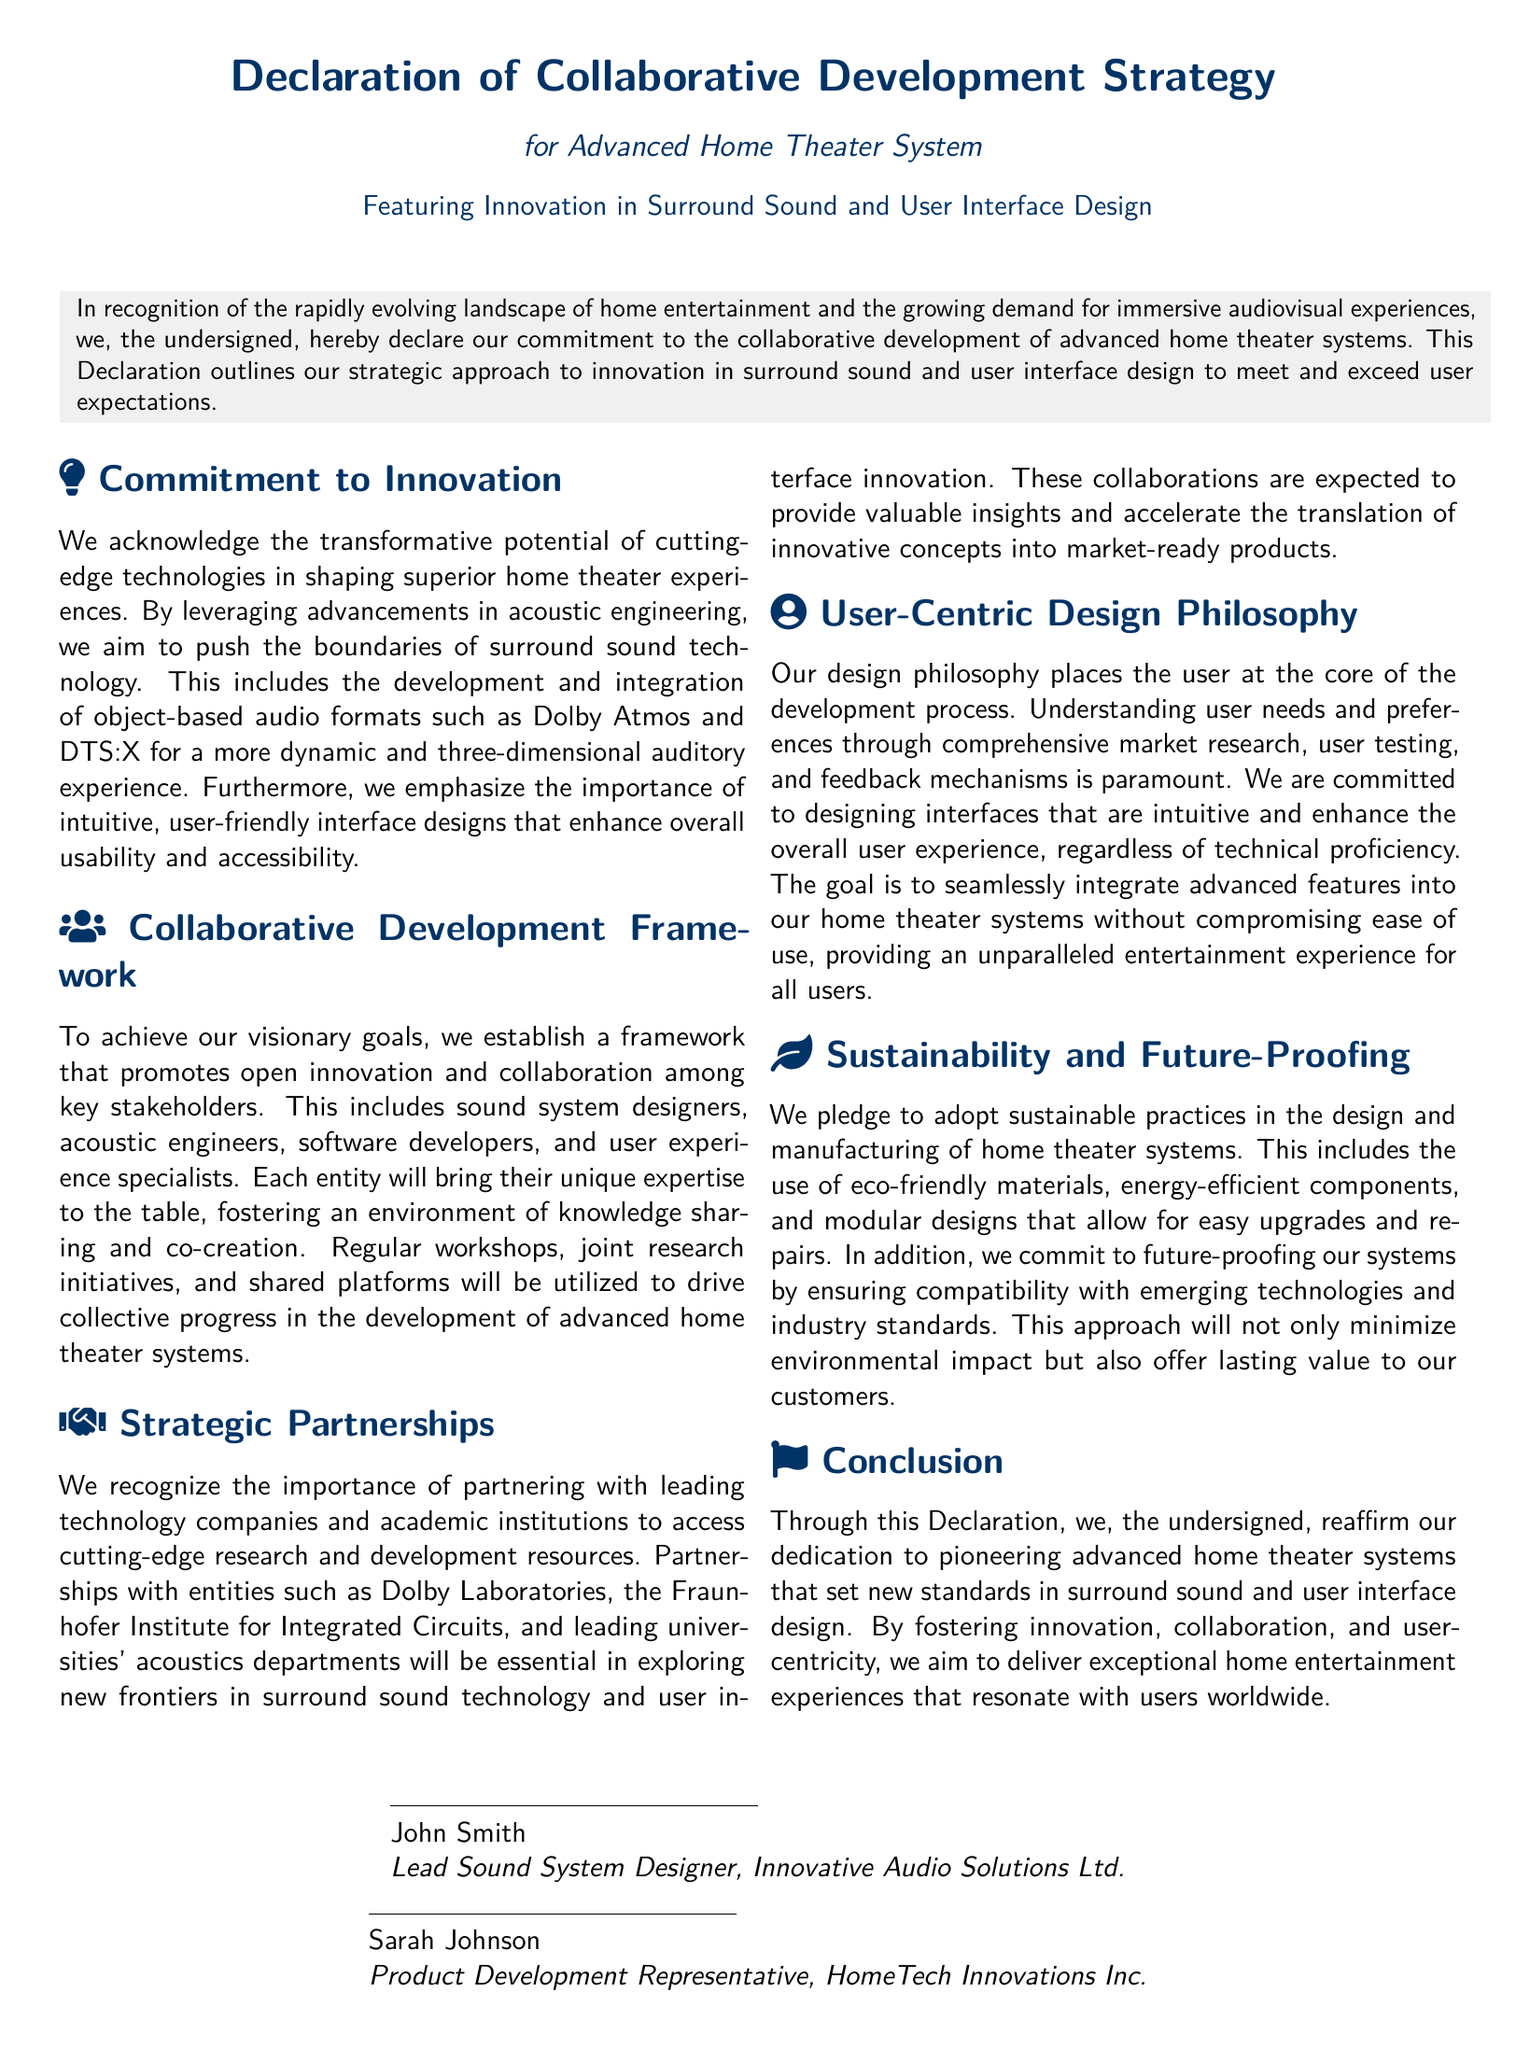what is the title of the document? The title of the document is prominently displayed at the top and identifies the purpose and scope of the document.
Answer: Declaration of Collaborative Development Strategy what system is this Declaration focusing on? The context of the Declaration clearly indicates the type of system being discussed in detail throughout the document.
Answer: Advanced Home Theater System what are the highlighted innovations mentioned? The key innovations emphasized are detailed in the commitment section, reflecting the focus areas of the development strategy.
Answer: Surround Sound and User Interface Design who is the lead sound system designer? The signature section at the bottom identifies the individuals signing the document and their roles in the collaboration.
Answer: John Smith how many main sections are in the document? The number of main sections can be counted from the document's layout, including the commitment to innovation and user-centric design among others.
Answer: Five which organization is associated with user-centric design philosophy? The document lists specific organizations involved in strategic partnerships and collaborative development efforts, one of which is relevant here.
Answer: HomeTech Innovations Inc what does the Declaration emphasize about user experience? The philosophy section outlines specific principles related to user experience as it pertains to system design.
Answer: Intuitive and enhance overall user experience what type of materials are to be used in manufacturing? The sustainability section discusses practices, giving insight into materials choice in the context of the home theater system production.
Answer: Eco-friendly materials who are the individuals signing the Declaration? The signatories provide names and titles indicating their roles in the collaborative effort detailed in the document.
Answer: John Smith and Sarah Johnson 